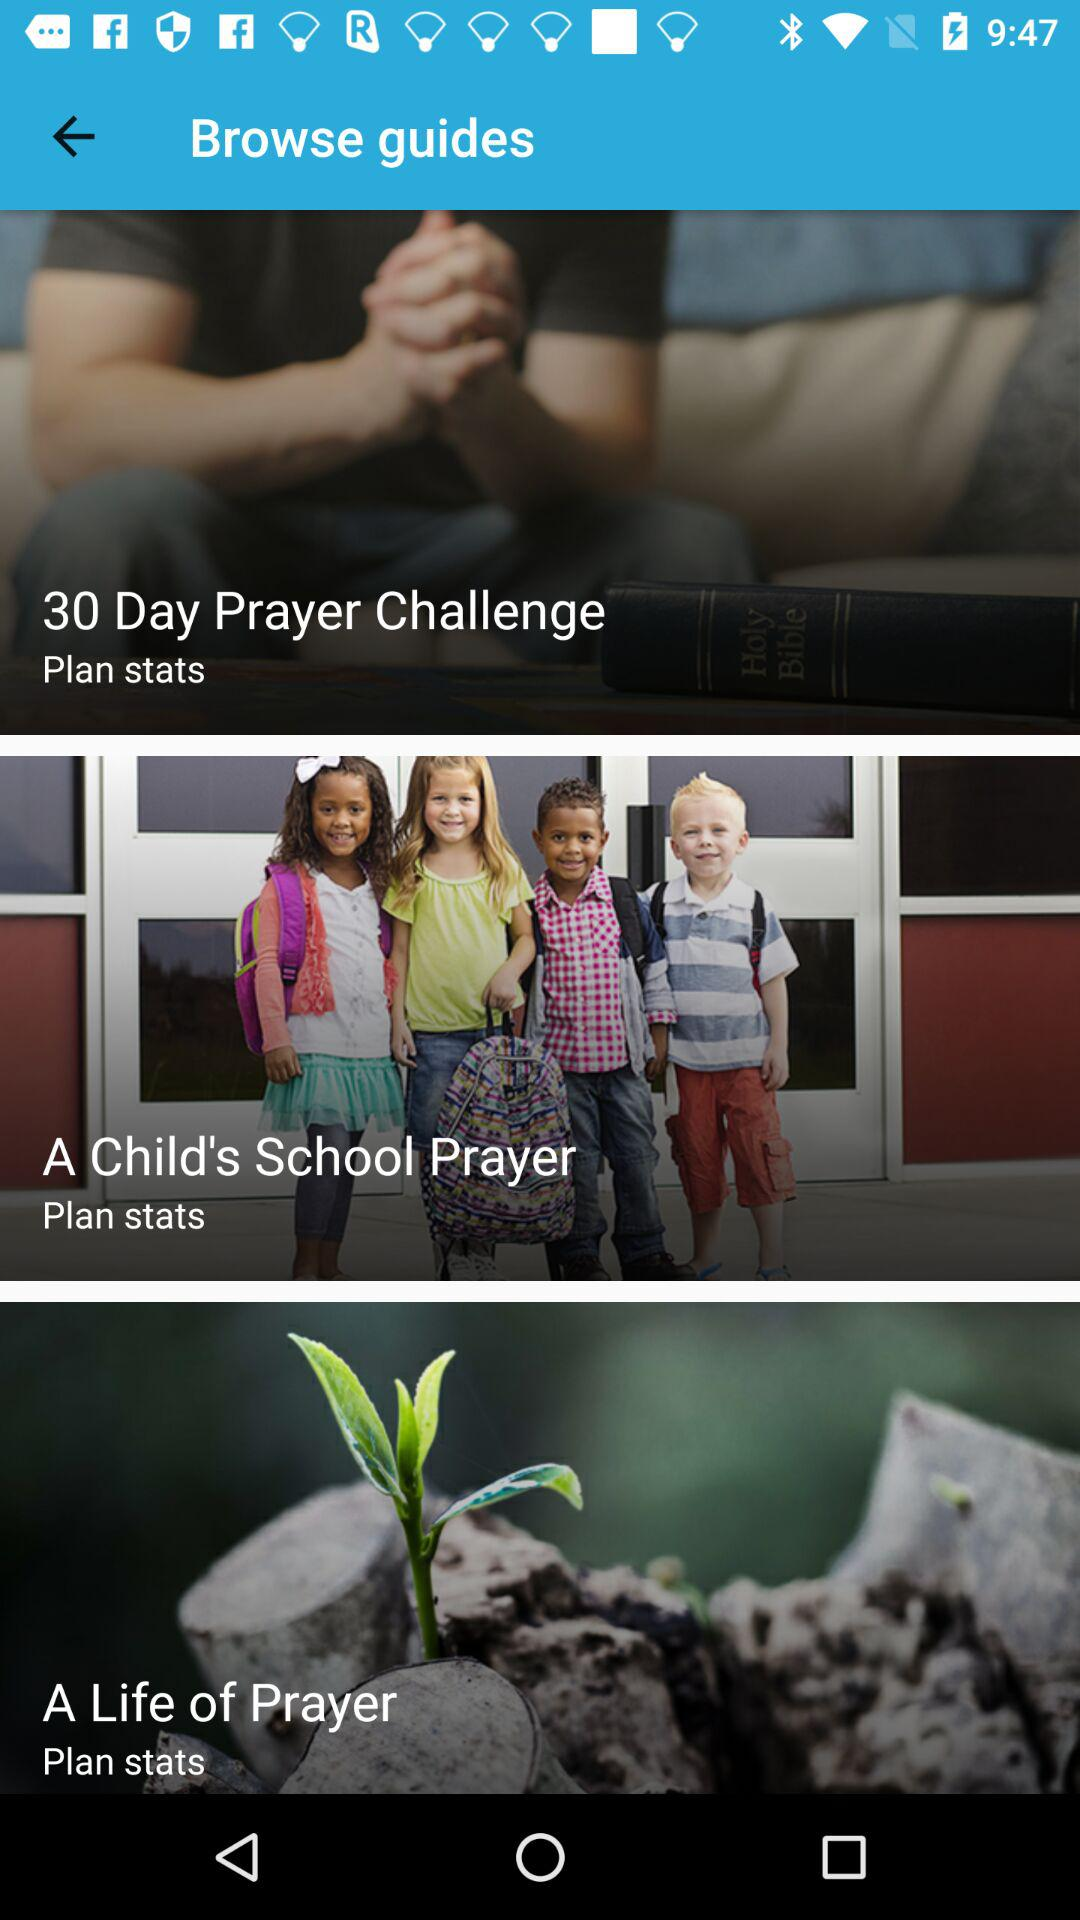How many guides are there?
Answer the question using a single word or phrase. 3 